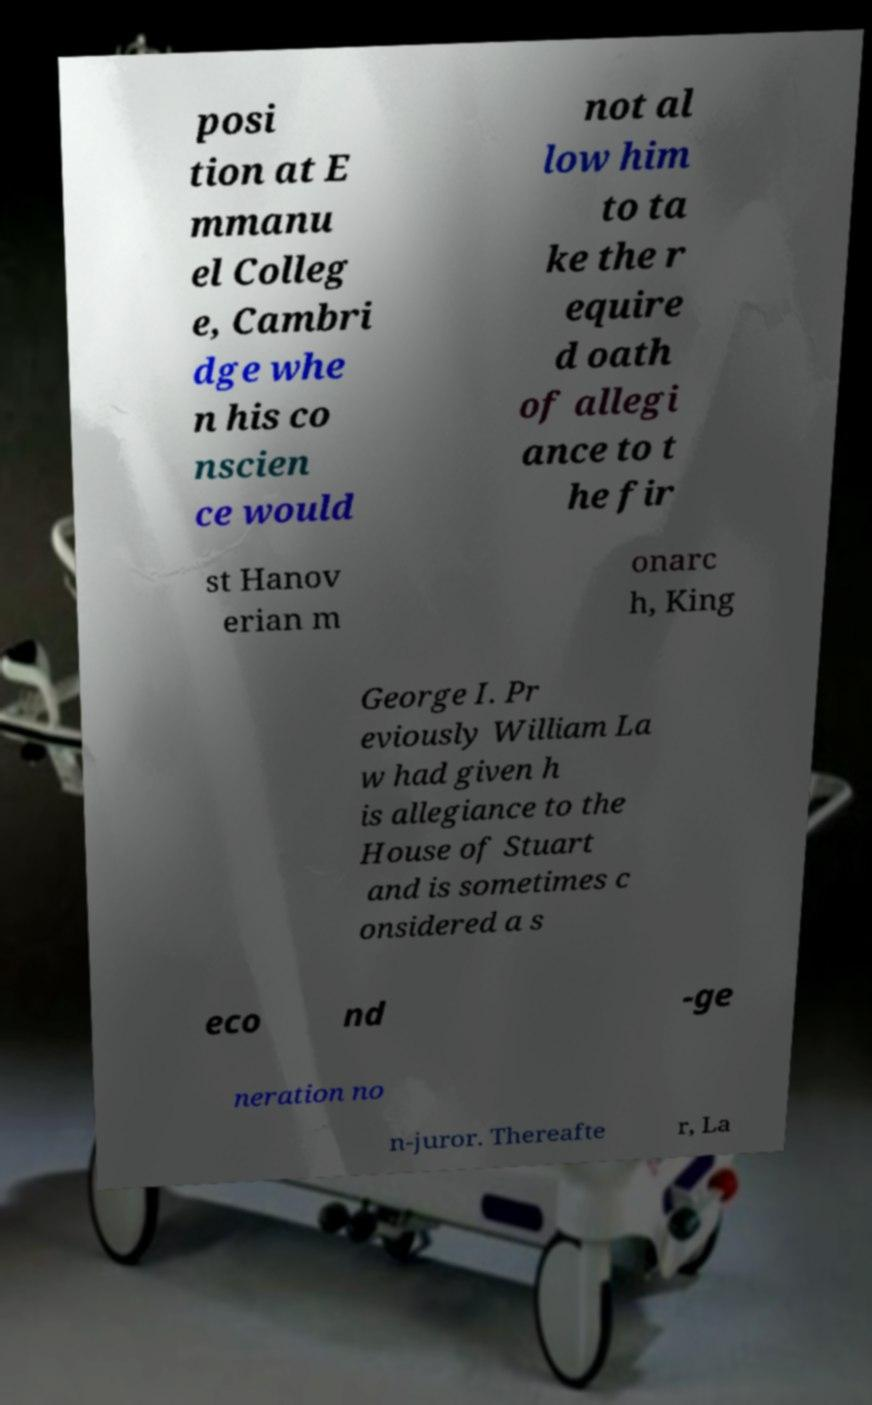Can you read and provide the text displayed in the image?This photo seems to have some interesting text. Can you extract and type it out for me? posi tion at E mmanu el Colleg e, Cambri dge whe n his co nscien ce would not al low him to ta ke the r equire d oath of allegi ance to t he fir st Hanov erian m onarc h, King George I. Pr eviously William La w had given h is allegiance to the House of Stuart and is sometimes c onsidered a s eco nd -ge neration no n-juror. Thereafte r, La 